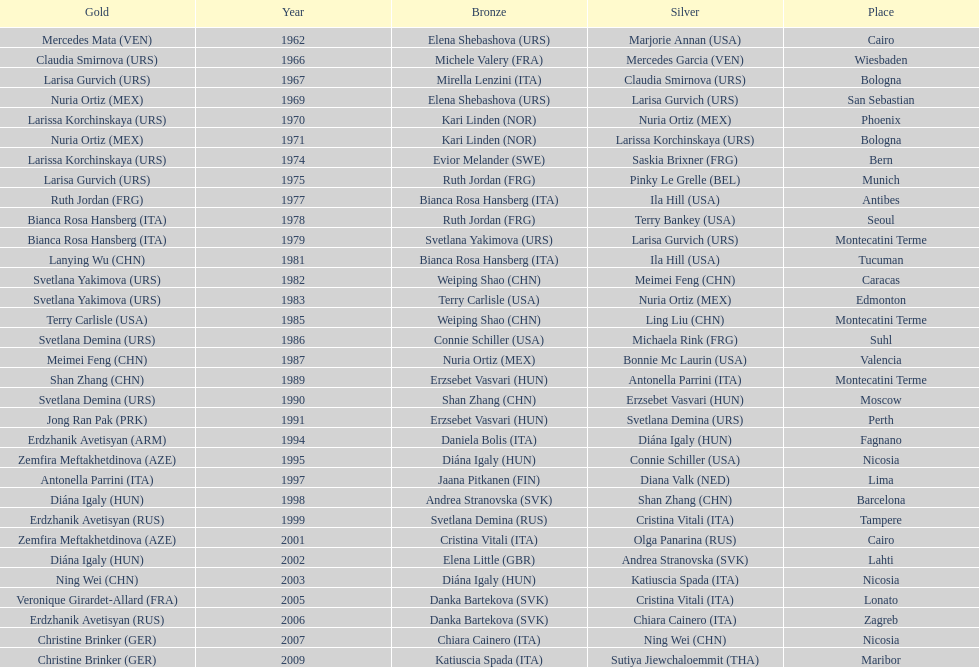In which country can you find the greatest amount of bronze medals? Italy. 